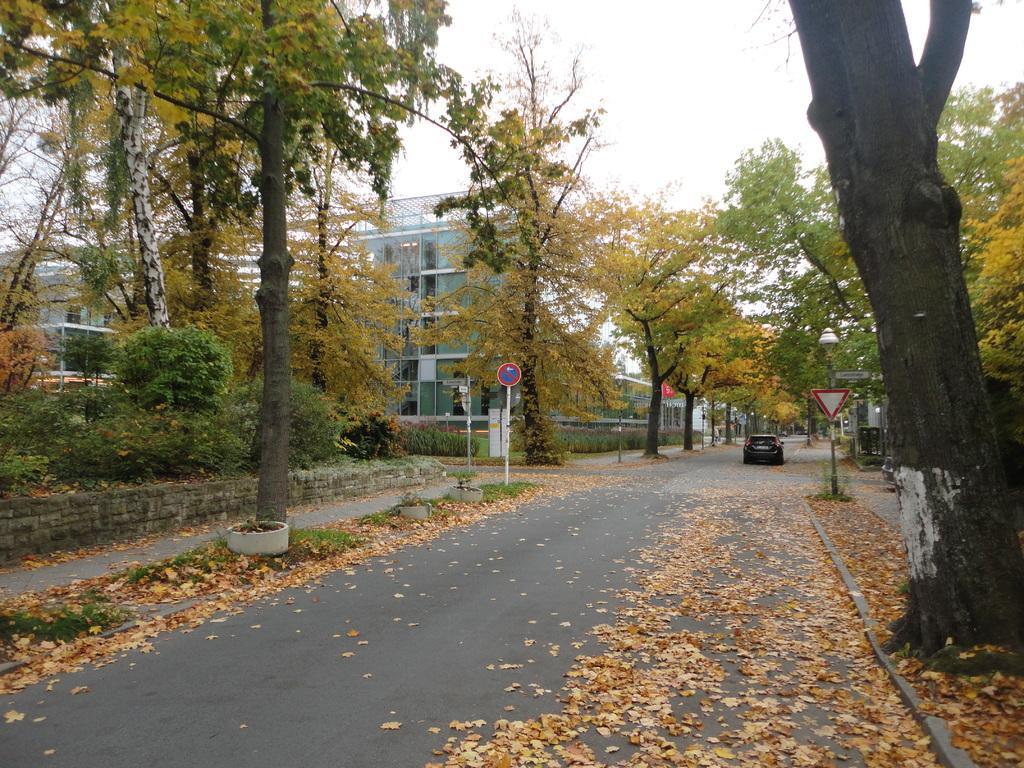Could you give a brief overview of what you see in this image? In this image, I can see dried leaves and a vehicle on the road. There are trees, buildings and sign boards attached to the poles. In the background, there is the sky. 